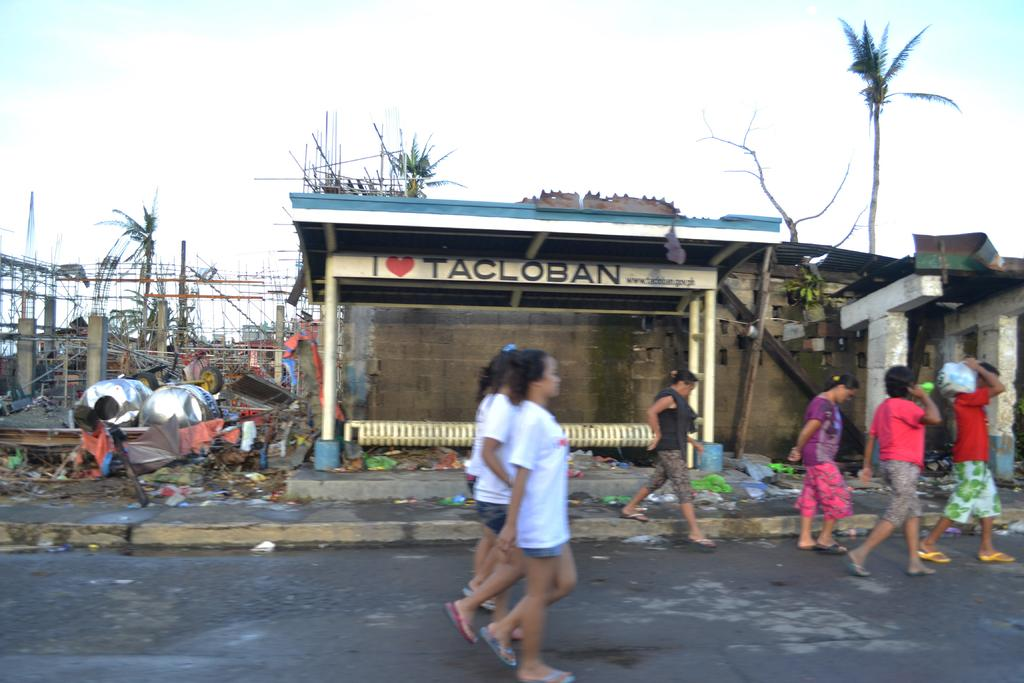What are the people in the image doing? The people in the image are walking. What type of natural elements can be seen in the image? There are trees in the image. What type of man-made structures are present in the image? There are buildings and a shelter in the image. What type of seating is available under the shelter? There is a metal bench under the shelter. What is the weather like in the image? The sky is cloudy in the image. What type of love can be seen between the trees in the image? There is no love present between the trees in the image; they are inanimate objects. What type of humor is depicted in the image? There is no humor depicted in the image; it is a scene of people walking, trees, buildings, and a shelter. 